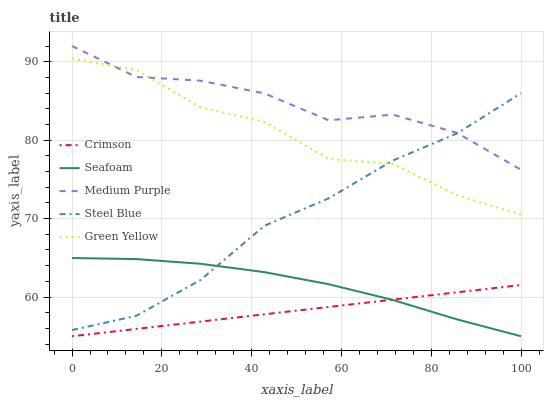Does Crimson have the minimum area under the curve?
Answer yes or no. Yes. Does Medium Purple have the maximum area under the curve?
Answer yes or no. Yes. Does Green Yellow have the minimum area under the curve?
Answer yes or no. No. Does Green Yellow have the maximum area under the curve?
Answer yes or no. No. Is Crimson the smoothest?
Answer yes or no. Yes. Is Green Yellow the roughest?
Answer yes or no. Yes. Is Medium Purple the smoothest?
Answer yes or no. No. Is Medium Purple the roughest?
Answer yes or no. No. Does Crimson have the lowest value?
Answer yes or no. Yes. Does Green Yellow have the lowest value?
Answer yes or no. No. Does Medium Purple have the highest value?
Answer yes or no. Yes. Does Green Yellow have the highest value?
Answer yes or no. No. Is Seafoam less than Medium Purple?
Answer yes or no. Yes. Is Medium Purple greater than Crimson?
Answer yes or no. Yes. Does Seafoam intersect Steel Blue?
Answer yes or no. Yes. Is Seafoam less than Steel Blue?
Answer yes or no. No. Is Seafoam greater than Steel Blue?
Answer yes or no. No. Does Seafoam intersect Medium Purple?
Answer yes or no. No. 